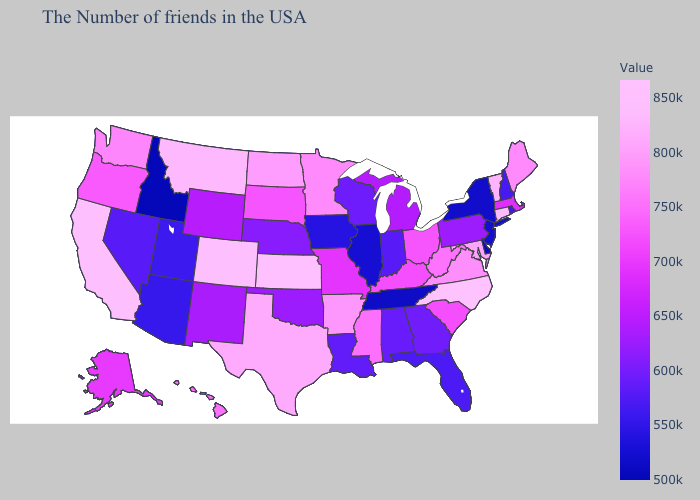Does the map have missing data?
Write a very short answer. No. Which states have the lowest value in the South?
Short answer required. Delaware. Does North Dakota have the highest value in the USA?
Answer briefly. No. 